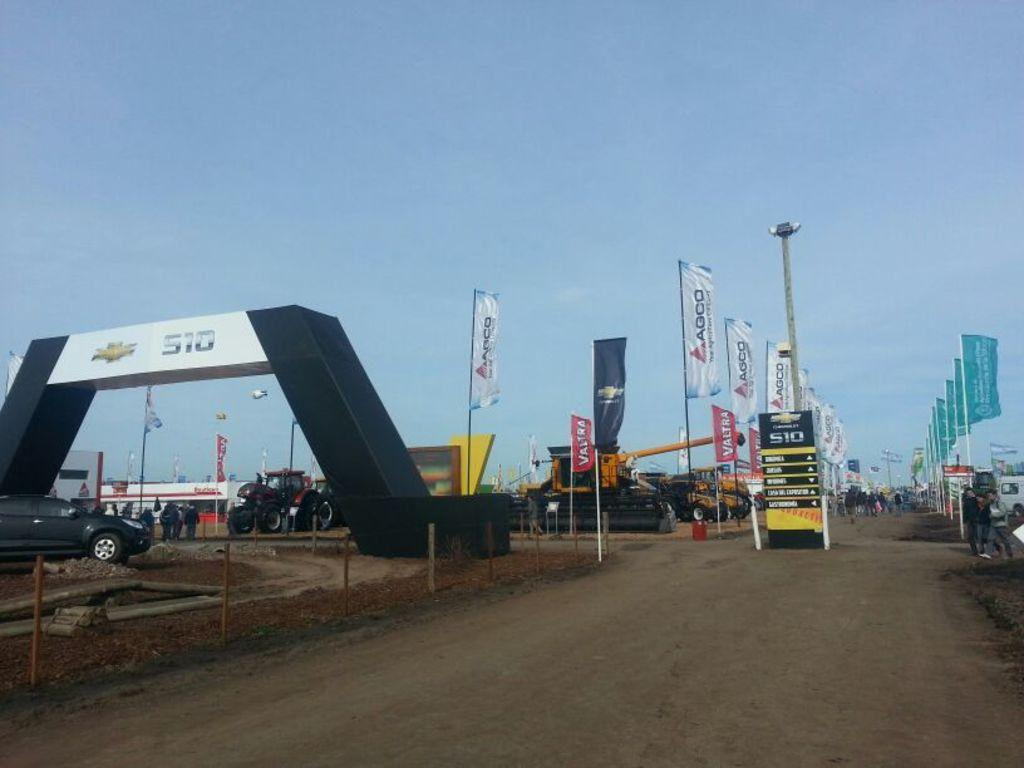What is hanging in the image? There are banners in the image. What can be observed about the appearance of the banners? The banners have multiple colors. What else can be seen in the image besides the banners? There are vehicles and people walking in the background. What is the color of the sky in the image? The sky is blue in the image. Can you tell me how many times the person in the image sneezed? There is no person sneezing in the image, so it is not possible to determine how many times they sneezed. What historical event is being commemorated by the banners in the image? The image does not provide any information about the historical event being commemorated by the banners. 